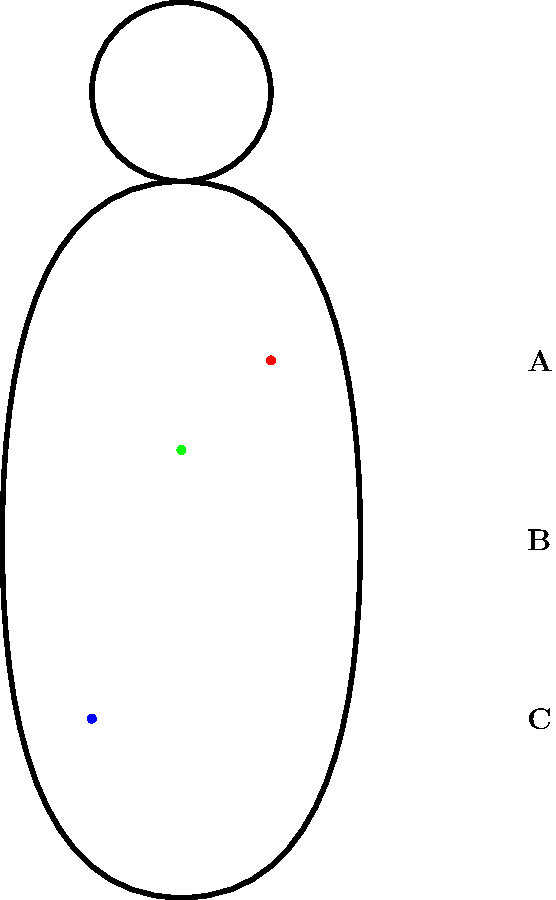Match the appropriate paramedic procedures (A, B, C) to the injury types indicated by colored dots on the body diagram:

Red dot: Head trauma
Blue dot: Leg fracture
Green dot: Chest pain

A: Apply cervical collar and backboard
B: Administer oxygen and perform ECG
C: Splint and elevate limb To match the appropriate paramedic procedures to the injury types, we need to consider each injury and its corresponding treatment:

1. Red dot (Head trauma):
   - Located on the upper part of the body, indicating a head injury
   - Head trauma requires immobilization to prevent further injury
   - Procedure A (Apply cervical collar and backboard) is the most appropriate for this injury

2. Blue dot (Leg fracture):
   - Located on the lower part of the body, indicating a leg injury
   - Fractures require stabilization and elevation to reduce pain and swelling
   - Procedure C (Splint and elevate limb) is the most appropriate for this injury

3. Green dot (Chest pain):
   - Located in the center of the chest area
   - Chest pain can be indicative of cardiac issues
   - Procedure B (Administer oxygen and perform ECG) is the most appropriate for this injury

Therefore, the correct matching is:
Red dot (Head trauma) - A (Apply cervical collar and backboard)
Blue dot (Leg fracture) - C (Splint and elevate limb)
Green dot (Chest pain) - B (Administer oxygen and perform ECG)
Answer: Red-A, Blue-C, Green-B 